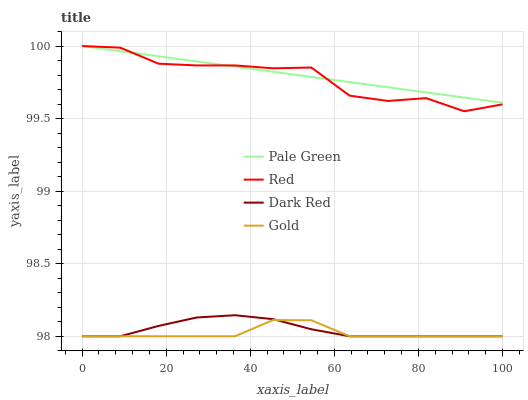Does Gold have the minimum area under the curve?
Answer yes or no. Yes. Does Pale Green have the maximum area under the curve?
Answer yes or no. Yes. Does Pale Green have the minimum area under the curve?
Answer yes or no. No. Does Gold have the maximum area under the curve?
Answer yes or no. No. Is Pale Green the smoothest?
Answer yes or no. Yes. Is Red the roughest?
Answer yes or no. Yes. Is Gold the smoothest?
Answer yes or no. No. Is Gold the roughest?
Answer yes or no. No. Does Dark Red have the lowest value?
Answer yes or no. Yes. Does Pale Green have the lowest value?
Answer yes or no. No. Does Red have the highest value?
Answer yes or no. Yes. Does Gold have the highest value?
Answer yes or no. No. Is Dark Red less than Red?
Answer yes or no. Yes. Is Pale Green greater than Dark Red?
Answer yes or no. Yes. Does Pale Green intersect Red?
Answer yes or no. Yes. Is Pale Green less than Red?
Answer yes or no. No. Is Pale Green greater than Red?
Answer yes or no. No. Does Dark Red intersect Red?
Answer yes or no. No. 